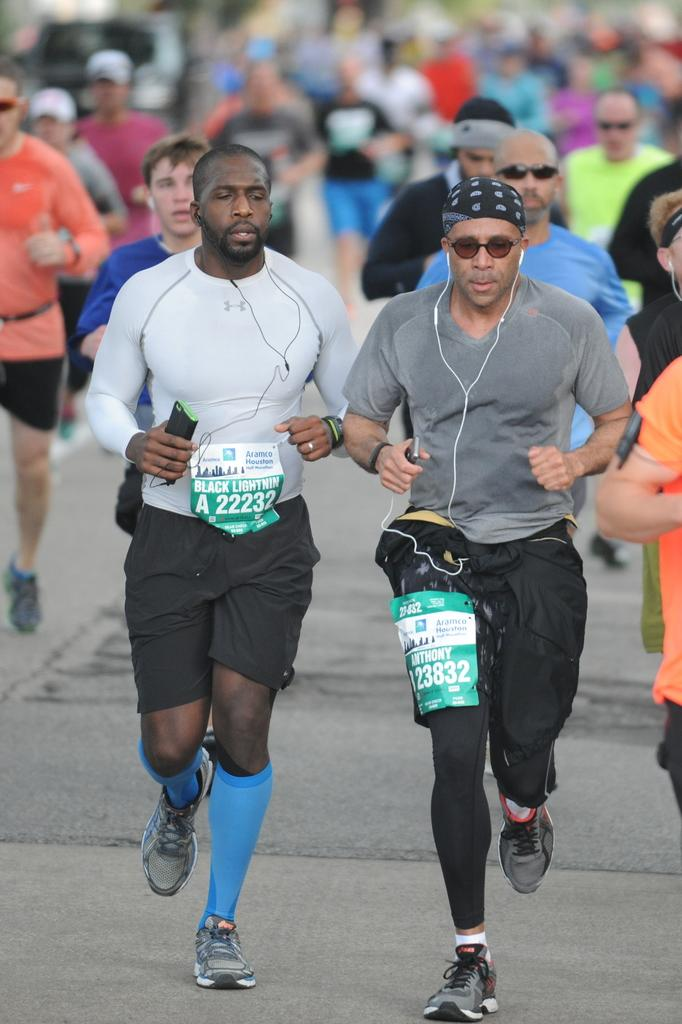What is happening in the image involving a group of people? In the image, there is a group of people running on the road. Are any of the people in the group holding any objects? Yes, three people in the group are holding mobile phones. What are the people holding mobile phones using in addition to their phones? The people holding mobile phones are wearing earphones. What type of sticks are the people using to run in the image? There are no sticks visible in the image; the people are running without any sticks. 